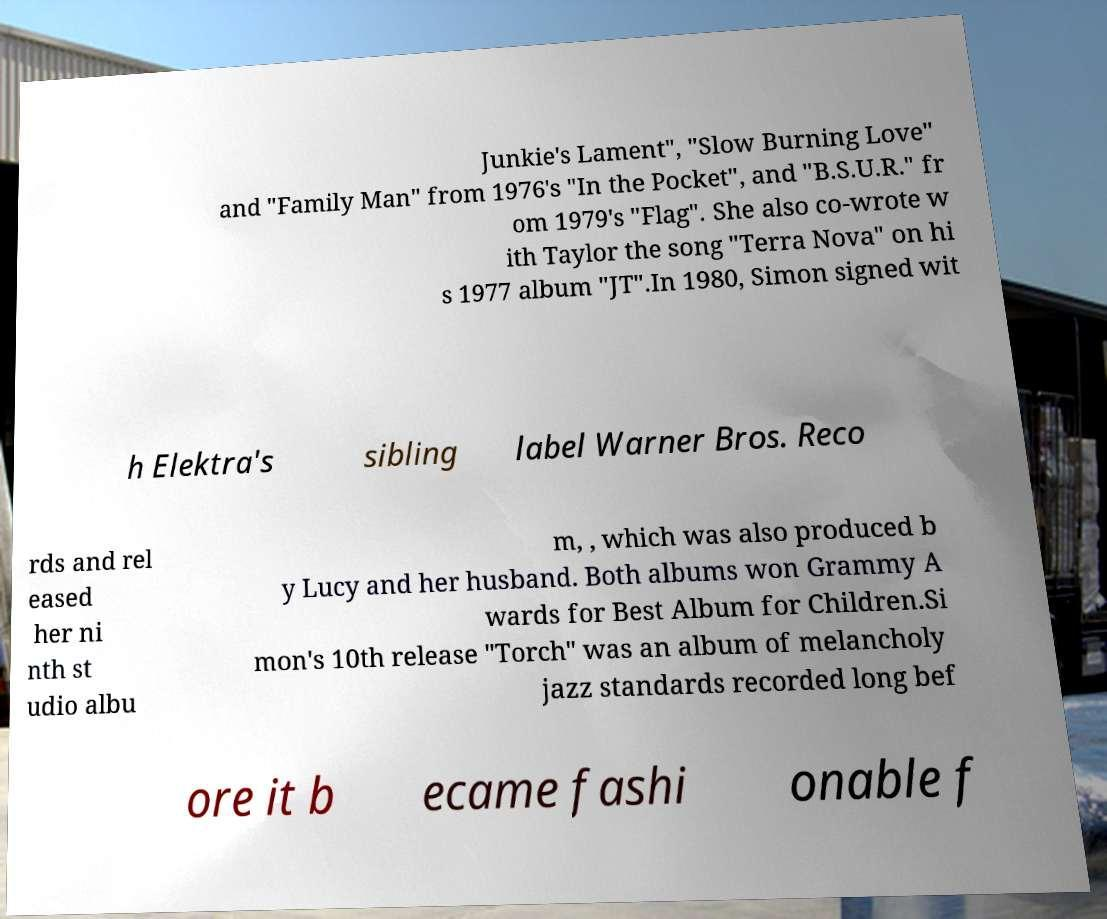Could you extract and type out the text from this image? Junkie's Lament", "Slow Burning Love" and "Family Man" from 1976's "In the Pocket", and "B.S.U.R." fr om 1979's "Flag". She also co-wrote w ith Taylor the song "Terra Nova" on hi s 1977 album "JT".In 1980, Simon signed wit h Elektra's sibling label Warner Bros. Reco rds and rel eased her ni nth st udio albu m, , which was also produced b y Lucy and her husband. Both albums won Grammy A wards for Best Album for Children.Si mon's 10th release "Torch" was an album of melancholy jazz standards recorded long bef ore it b ecame fashi onable f 